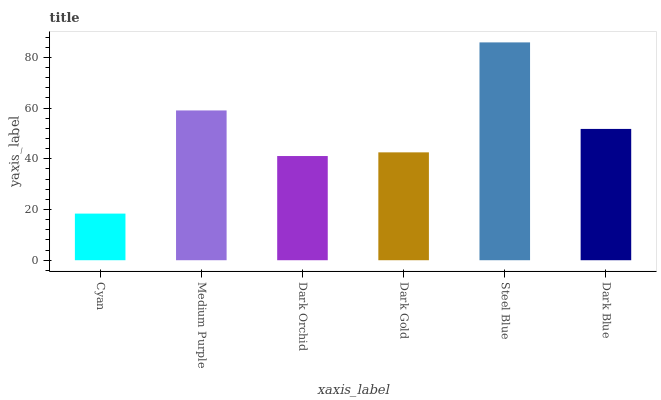Is Cyan the minimum?
Answer yes or no. Yes. Is Steel Blue the maximum?
Answer yes or no. Yes. Is Medium Purple the minimum?
Answer yes or no. No. Is Medium Purple the maximum?
Answer yes or no. No. Is Medium Purple greater than Cyan?
Answer yes or no. Yes. Is Cyan less than Medium Purple?
Answer yes or no. Yes. Is Cyan greater than Medium Purple?
Answer yes or no. No. Is Medium Purple less than Cyan?
Answer yes or no. No. Is Dark Blue the high median?
Answer yes or no. Yes. Is Dark Gold the low median?
Answer yes or no. Yes. Is Dark Gold the high median?
Answer yes or no. No. Is Medium Purple the low median?
Answer yes or no. No. 